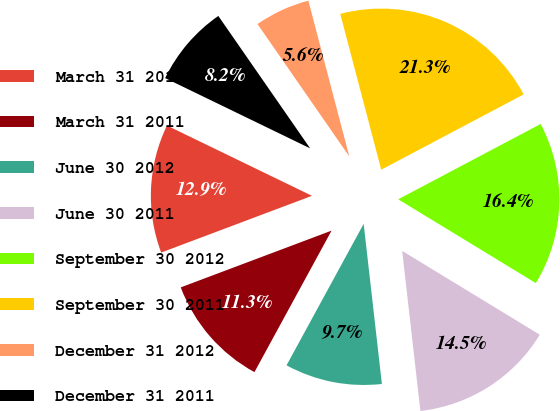<chart> <loc_0><loc_0><loc_500><loc_500><pie_chart><fcel>March 31 2012<fcel>March 31 2011<fcel>June 30 2012<fcel>June 30 2011<fcel>September 30 2012<fcel>September 30 2011<fcel>December 31 2012<fcel>December 31 2011<nl><fcel>12.91%<fcel>11.33%<fcel>9.75%<fcel>14.49%<fcel>16.45%<fcel>21.35%<fcel>5.56%<fcel>8.17%<nl></chart> 